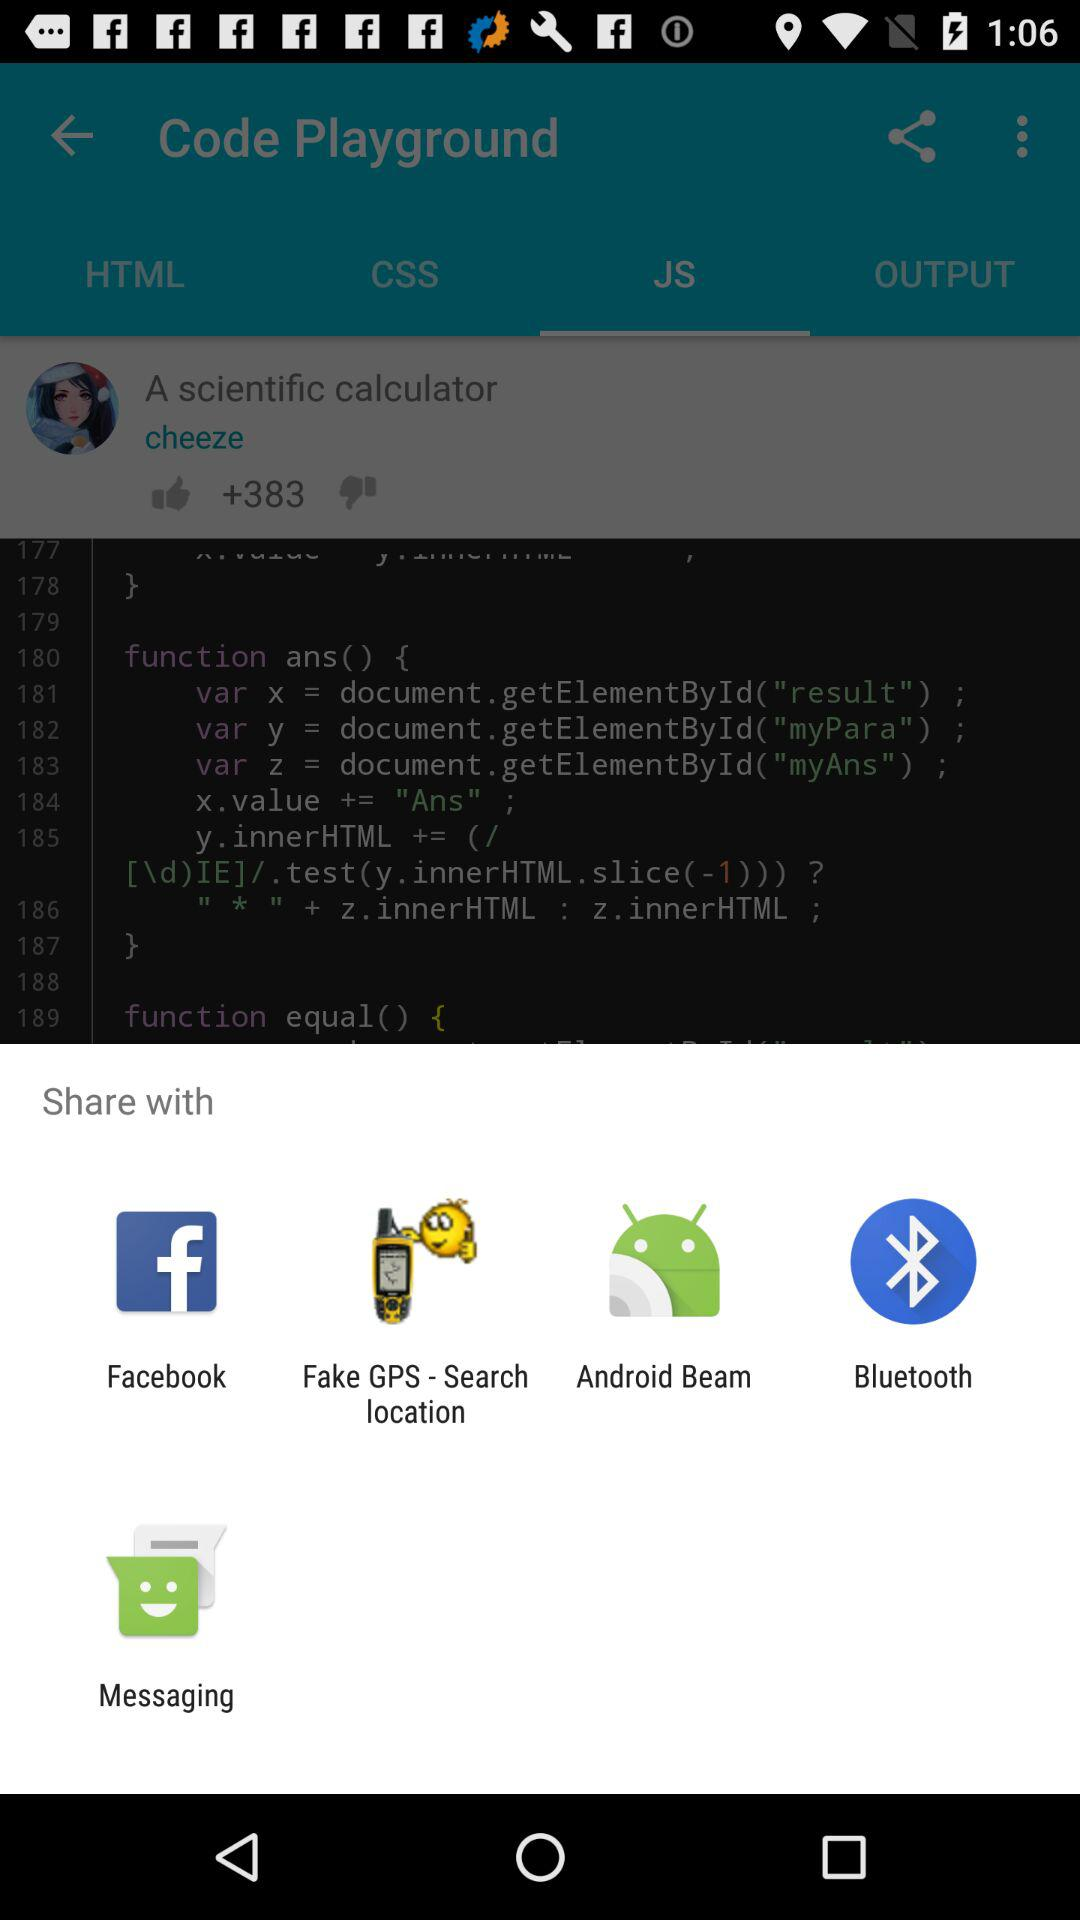What are the different mediums to share? The different mediums to share are "Facebook", "Fake GPS-Search location", "Android Beam", "Bluetooth", and "Messaging". 